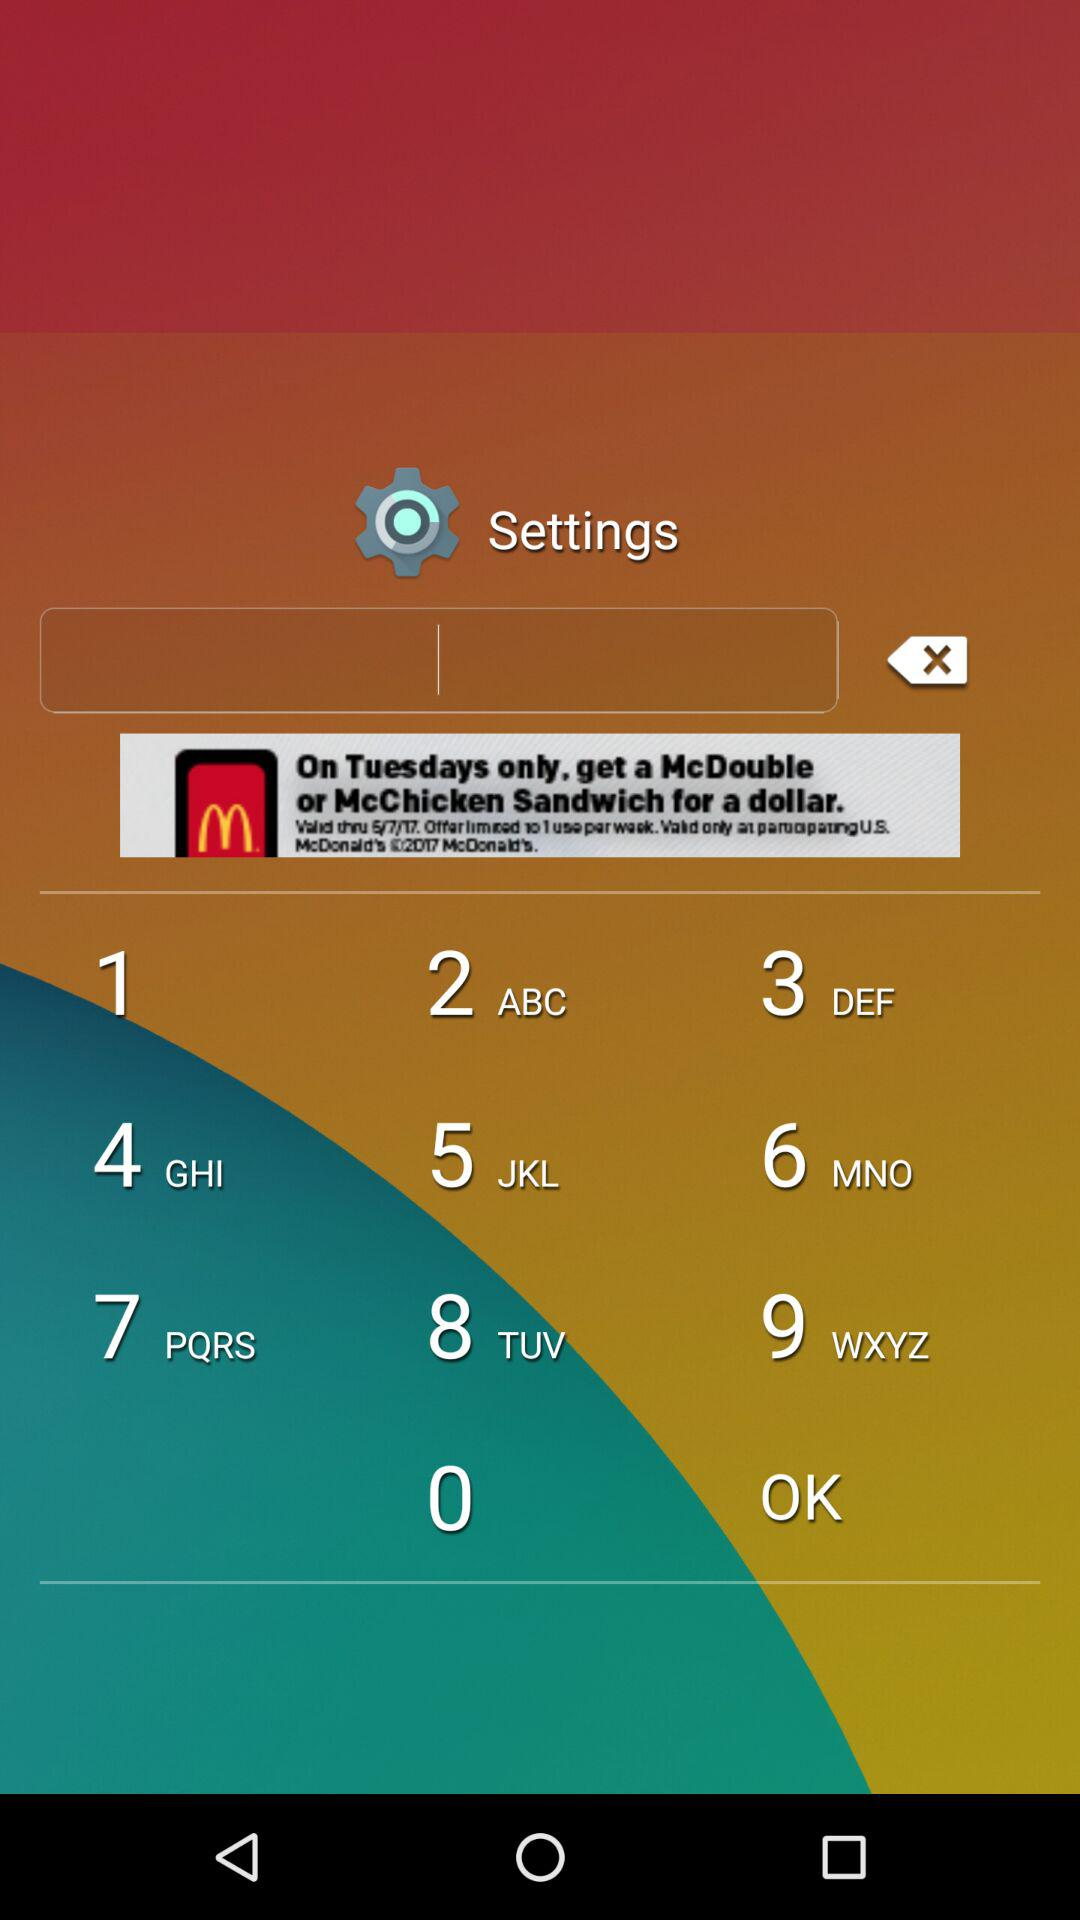What does the fifth point say?
When the provided information is insufficient, respond with <no answer>. <no answer> 